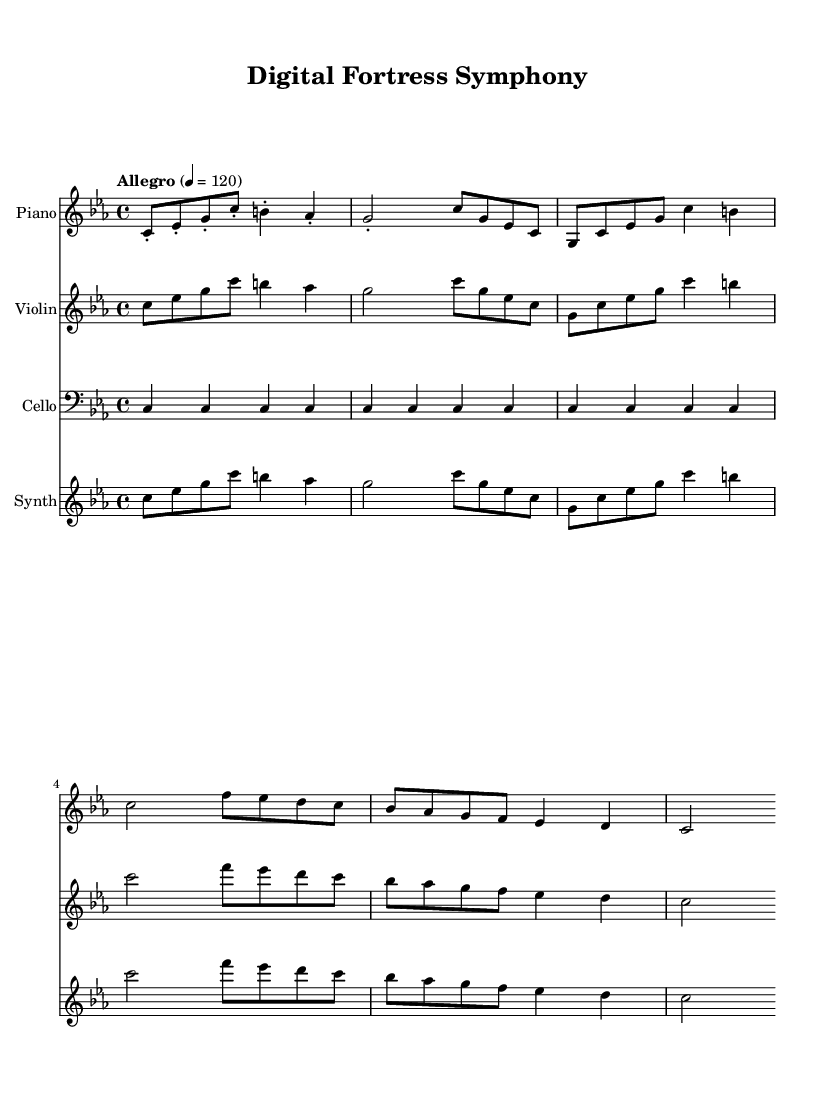What is the key signature of this music? The key signature indicated in the music is C minor, which is represented by three flats (B♭, E♭, and A♭).
Answer: C minor What is the time signature of this music? The time signature shown is 4/4, which means there are four beats per measure and each quarter note gets one beat.
Answer: 4/4 What is the tempo marking for this music? The tempo marking is indicated as "Allegro," which is typically a fast and lively tempo, set at the quarter note equals 120 beats per minute.
Answer: Allegro Which instruments are featured in this piece? The piece features a piano, violin, cello, and synthesizer, listed in the score.
Answer: Piano, violin, cello, synthesizer How many measures are in the piano part? By counting the distinct groupings of notes grouped into measures, there are a total of six measures visible in the piano part.
Answer: 6 What is the rhythmic pattern of the first measure in the violin part? The first measure in the violin part consists of a series of eighth notes, which contribute to a lively rhythm. It contains four eighth notes: C, E♭, G, and C.
Answer: Eighth notes How does the cello part differ from the other instruments? The cello part is distinct because it consists solely of quarter notes that repeat a single pitch throughout the four measures, creating a grounding effect in the harmony.
Answer: Repetitive quarter notes 